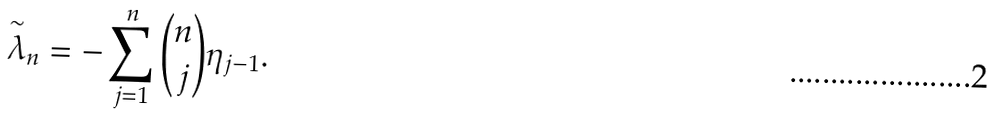Convert formula to latex. <formula><loc_0><loc_0><loc_500><loc_500>\overset { \sim } { \lambda } _ { n } = - \sum _ { j = 1 } ^ { n } \binom { n } { j } \eta _ { j - 1 } .</formula> 